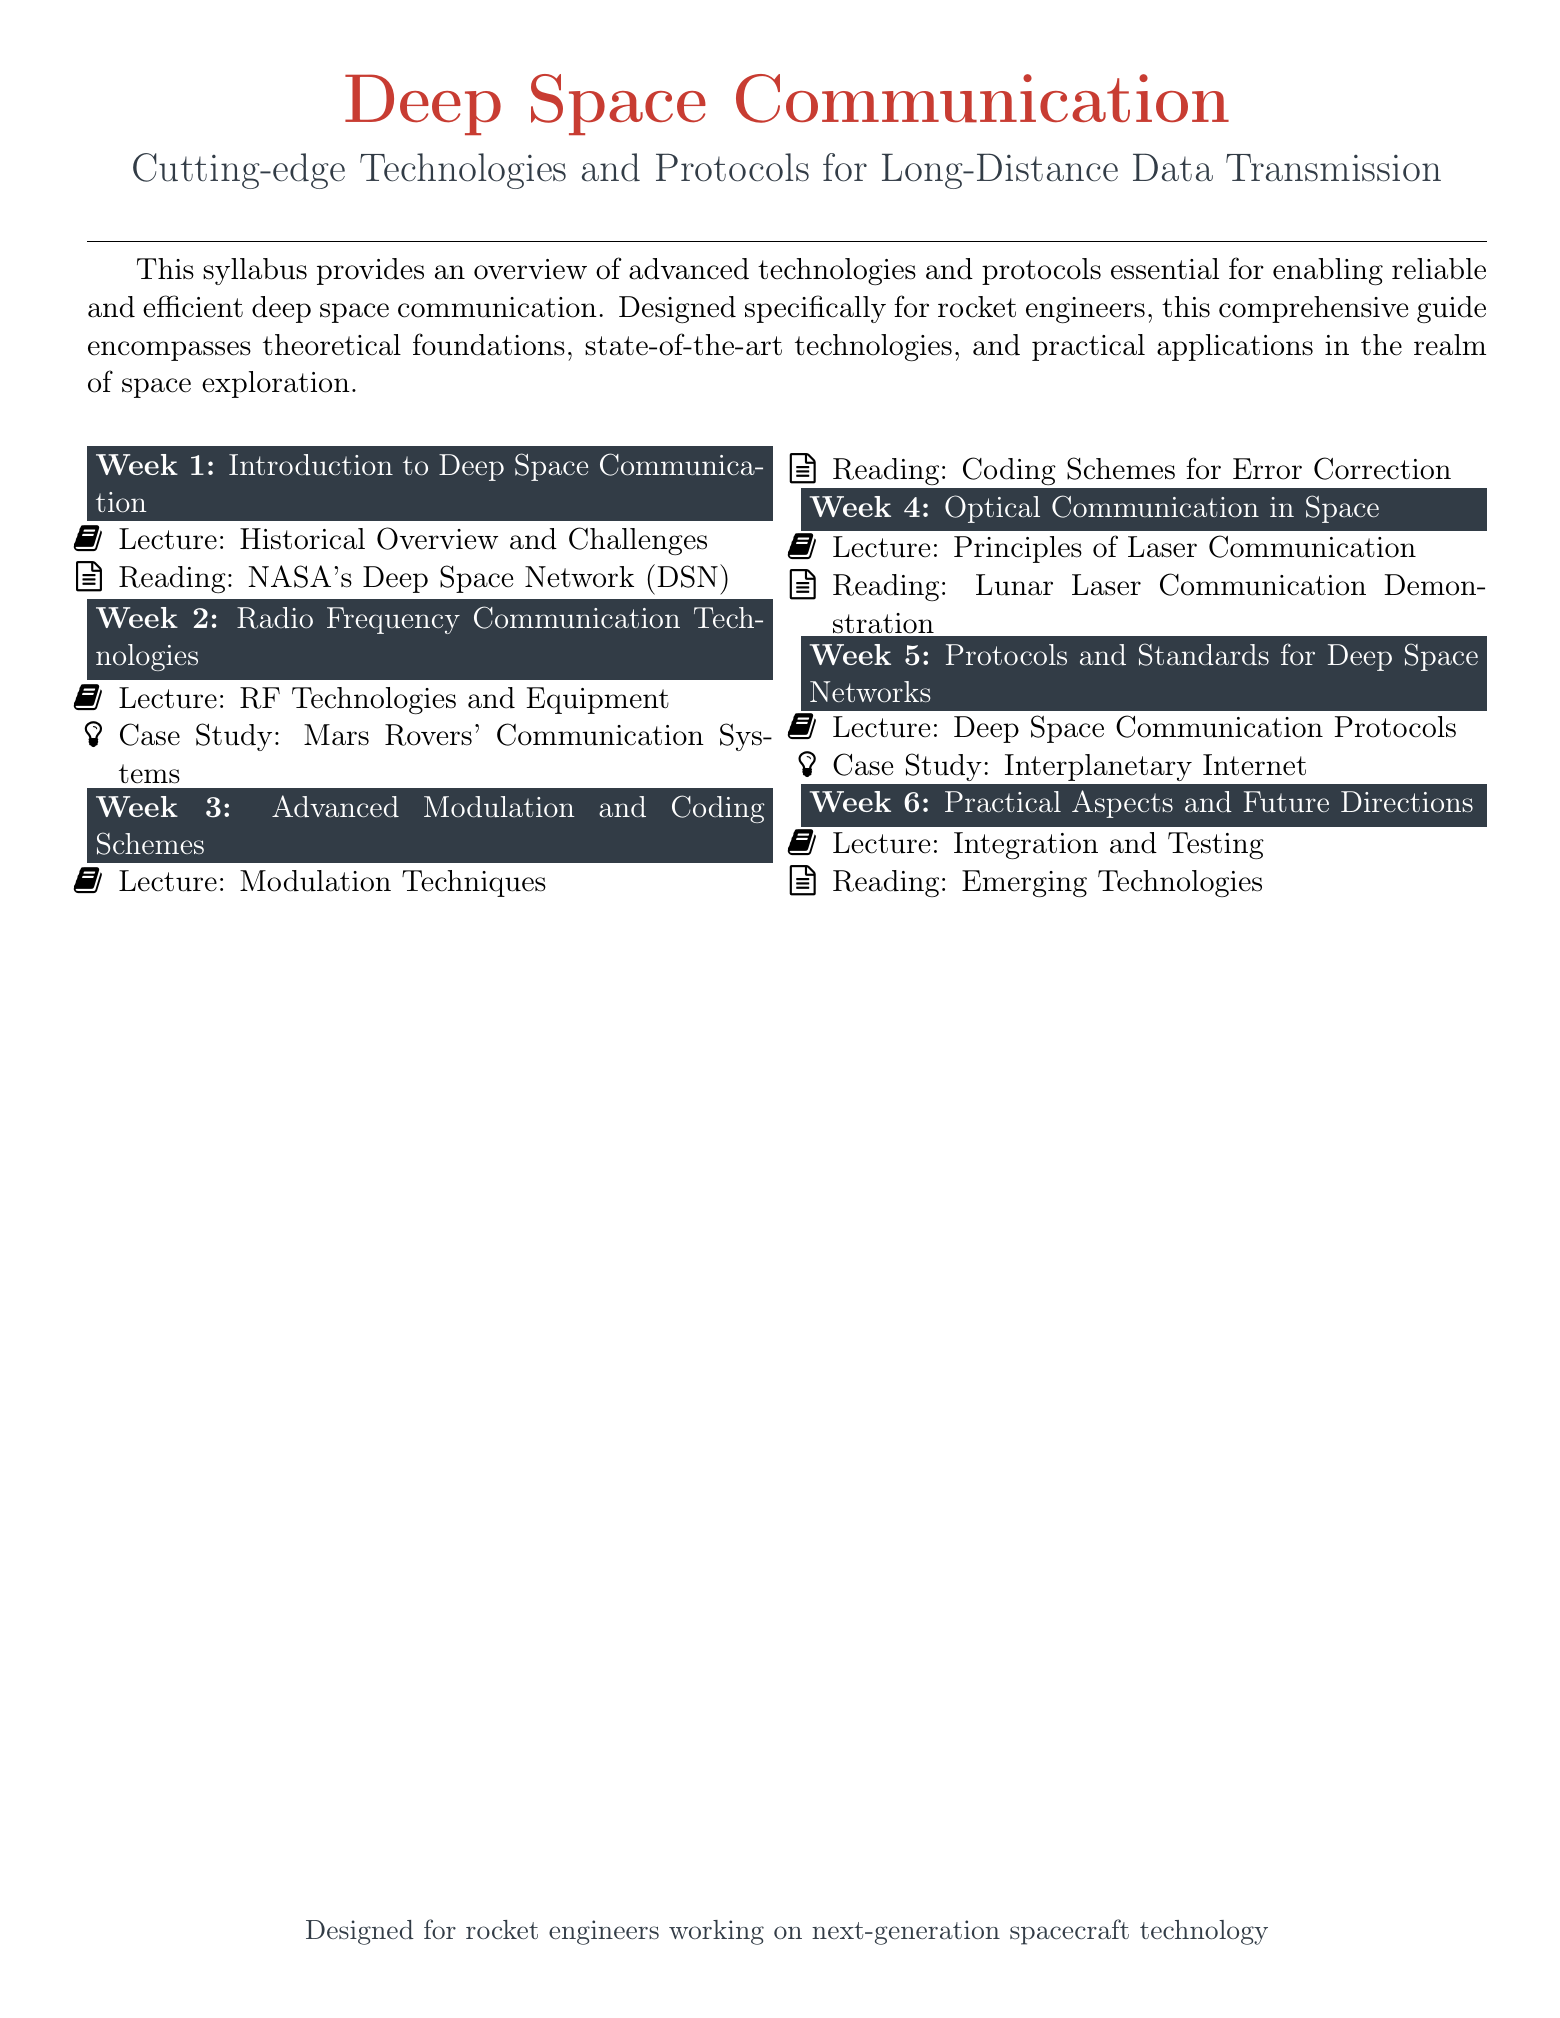What is the title of the syllabus? The title of the syllabus is provided prominently at the beginning of the document.
Answer: Deep Space Communication How many weeks does the syllabus cover? The syllabus section headers indicate the number of weeks covered.
Answer: 6 What is the focus of Week 4? Week 4's focus is indicated in the section header.
Answer: Optical Communication in Space What is the case study associated with Week 5? The case study for Week 5 is mentioned in the items listed under that week.
Answer: Interplanetary Internet What technology is emphasized in Week 3? The emphasis for Week 3 is found in the title of that week's focus.
Answer: Advanced Modulation and Coding Schemes What type of reading is listed for Week 1? The type of reading is specified in the item for that week.
Answer: NASA's Deep Space Network (DSN) Which section discusses integration and testing? The section that discusses integration and testing is identified by the week header.
Answer: Week 6 Which technology is highlighted in Week 4's lecture? The technology highlighted in Week 4's lecture is noted in the lecture title.
Answer: Laser Communication What color is the theme used for section titles? The document uses a specific color for section titles that can be determined by examining the format.
Answer: Spacered Who is the syllabus designed for? The target audience is specified in the concluding part of the document.
Answer: Rocket engineers 